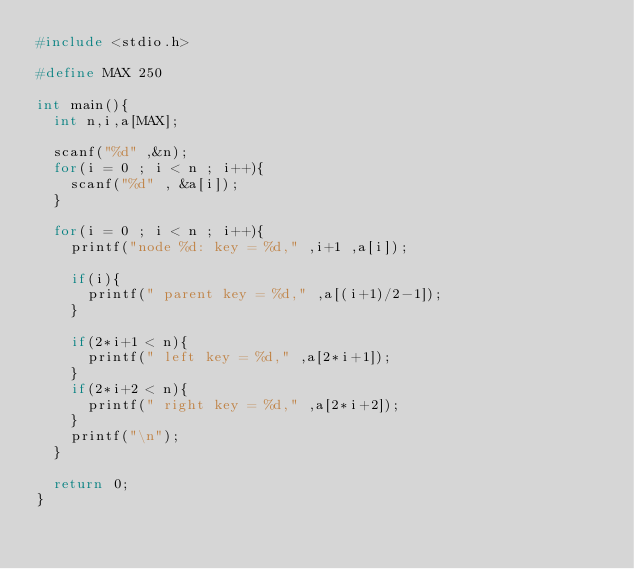Convert code to text. <code><loc_0><loc_0><loc_500><loc_500><_C_>#include <stdio.h>

#define MAX 250

int main(){
  int n,i,a[MAX];

  scanf("%d" ,&n);
  for(i = 0 ; i < n ; i++){
    scanf("%d" , &a[i]);
  }

  for(i = 0 ; i < n ; i++){
    printf("node %d: key = %d," ,i+1 ,a[i]);

    if(i){
      printf(" parent key = %d," ,a[(i+1)/2-1]);
    }

    if(2*i+1 < n){
      printf(" left key = %d," ,a[2*i+1]);
    }
    if(2*i+2 < n){
      printf(" right key = %d," ,a[2*i+2]);
    }
    printf("\n");
  }

  return 0;
}</code> 